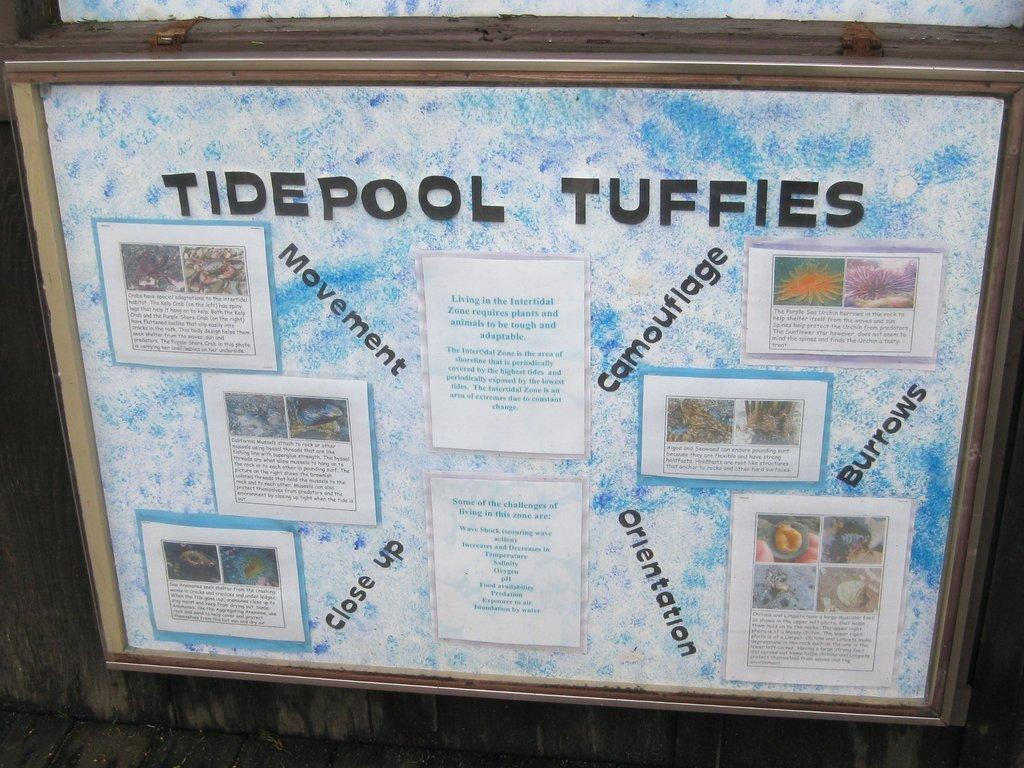<image>
Give a short and clear explanation of the subsequent image. A display board titled Tidepool Tuffies with an assortment of photos and text images. 